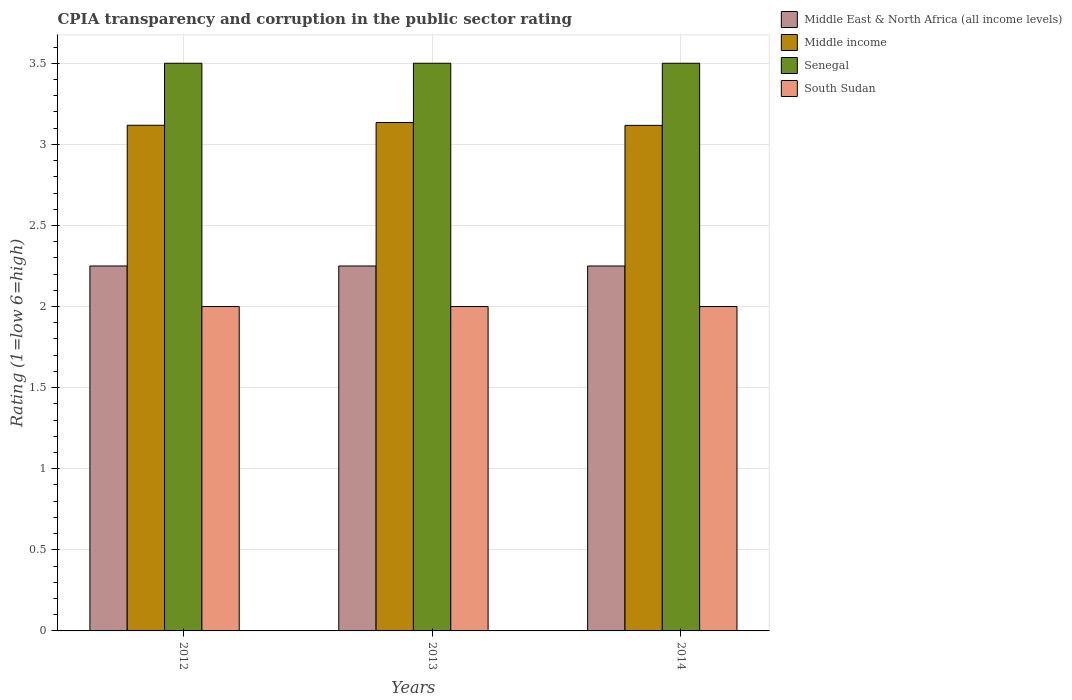How many different coloured bars are there?
Provide a succinct answer. 4. How many bars are there on the 1st tick from the right?
Provide a short and direct response. 4. Across all years, what is the maximum CPIA rating in Middle East & North Africa (all income levels)?
Your response must be concise. 2.25. Across all years, what is the minimum CPIA rating in Senegal?
Provide a succinct answer. 3.5. In which year was the CPIA rating in Middle East & North Africa (all income levels) maximum?
Your answer should be compact. 2012. What is the total CPIA rating in Middle East & North Africa (all income levels) in the graph?
Give a very brief answer. 6.75. What is the difference between the CPIA rating in South Sudan in 2013 and that in 2014?
Your answer should be very brief. 0. What is the difference between the CPIA rating in Middle income in 2014 and the CPIA rating in South Sudan in 2012?
Your answer should be compact. 1.12. In the year 2014, what is the difference between the CPIA rating in Senegal and CPIA rating in Middle income?
Offer a terse response. 0.38. In how many years, is the CPIA rating in Middle income greater than 0.5?
Provide a succinct answer. 3. What is the difference between the highest and the second highest CPIA rating in Senegal?
Keep it short and to the point. 0. What is the difference between the highest and the lowest CPIA rating in Senegal?
Make the answer very short. 0. In how many years, is the CPIA rating in Middle East & North Africa (all income levels) greater than the average CPIA rating in Middle East & North Africa (all income levels) taken over all years?
Your response must be concise. 0. Is the sum of the CPIA rating in Senegal in 2012 and 2014 greater than the maximum CPIA rating in Middle East & North Africa (all income levels) across all years?
Your response must be concise. Yes. Is it the case that in every year, the sum of the CPIA rating in Middle East & North Africa (all income levels) and CPIA rating in Middle income is greater than the sum of CPIA rating in South Sudan and CPIA rating in Senegal?
Your answer should be compact. No. What does the 4th bar from the left in 2013 represents?
Your answer should be very brief. South Sudan. What does the 4th bar from the right in 2012 represents?
Ensure brevity in your answer.  Middle East & North Africa (all income levels). How many bars are there?
Your answer should be very brief. 12. How many years are there in the graph?
Your response must be concise. 3. Are the values on the major ticks of Y-axis written in scientific E-notation?
Make the answer very short. No. What is the title of the graph?
Ensure brevity in your answer.  CPIA transparency and corruption in the public sector rating. What is the label or title of the X-axis?
Provide a short and direct response. Years. What is the Rating (1=low 6=high) in Middle East & North Africa (all income levels) in 2012?
Provide a succinct answer. 2.25. What is the Rating (1=low 6=high) of Middle income in 2012?
Offer a terse response. 3.12. What is the Rating (1=low 6=high) in South Sudan in 2012?
Your response must be concise. 2. What is the Rating (1=low 6=high) of Middle East & North Africa (all income levels) in 2013?
Offer a terse response. 2.25. What is the Rating (1=low 6=high) of Middle income in 2013?
Keep it short and to the point. 3.13. What is the Rating (1=low 6=high) in South Sudan in 2013?
Keep it short and to the point. 2. What is the Rating (1=low 6=high) in Middle East & North Africa (all income levels) in 2014?
Your answer should be very brief. 2.25. What is the Rating (1=low 6=high) in Middle income in 2014?
Ensure brevity in your answer.  3.12. What is the Rating (1=low 6=high) in South Sudan in 2014?
Offer a terse response. 2. Across all years, what is the maximum Rating (1=low 6=high) in Middle East & North Africa (all income levels)?
Make the answer very short. 2.25. Across all years, what is the maximum Rating (1=low 6=high) of Middle income?
Your answer should be very brief. 3.13. Across all years, what is the maximum Rating (1=low 6=high) of Senegal?
Provide a succinct answer. 3.5. Across all years, what is the minimum Rating (1=low 6=high) of Middle East & North Africa (all income levels)?
Give a very brief answer. 2.25. Across all years, what is the minimum Rating (1=low 6=high) of Middle income?
Offer a very short reply. 3.12. Across all years, what is the minimum Rating (1=low 6=high) of South Sudan?
Your answer should be very brief. 2. What is the total Rating (1=low 6=high) of Middle East & North Africa (all income levels) in the graph?
Your answer should be compact. 6.75. What is the total Rating (1=low 6=high) in Middle income in the graph?
Make the answer very short. 9.37. What is the difference between the Rating (1=low 6=high) in Middle income in 2012 and that in 2013?
Provide a succinct answer. -0.02. What is the difference between the Rating (1=low 6=high) in Senegal in 2012 and that in 2013?
Offer a terse response. 0. What is the difference between the Rating (1=low 6=high) of South Sudan in 2012 and that in 2013?
Make the answer very short. 0. What is the difference between the Rating (1=low 6=high) in Middle East & North Africa (all income levels) in 2012 and that in 2014?
Keep it short and to the point. 0. What is the difference between the Rating (1=low 6=high) of Middle income in 2012 and that in 2014?
Offer a very short reply. 0. What is the difference between the Rating (1=low 6=high) in Senegal in 2012 and that in 2014?
Provide a short and direct response. 0. What is the difference between the Rating (1=low 6=high) in South Sudan in 2012 and that in 2014?
Offer a terse response. 0. What is the difference between the Rating (1=low 6=high) of Middle income in 2013 and that in 2014?
Your answer should be very brief. 0.02. What is the difference between the Rating (1=low 6=high) in South Sudan in 2013 and that in 2014?
Give a very brief answer. 0. What is the difference between the Rating (1=low 6=high) of Middle East & North Africa (all income levels) in 2012 and the Rating (1=low 6=high) of Middle income in 2013?
Provide a succinct answer. -0.88. What is the difference between the Rating (1=low 6=high) of Middle East & North Africa (all income levels) in 2012 and the Rating (1=low 6=high) of Senegal in 2013?
Offer a very short reply. -1.25. What is the difference between the Rating (1=low 6=high) of Middle East & North Africa (all income levels) in 2012 and the Rating (1=low 6=high) of South Sudan in 2013?
Provide a short and direct response. 0.25. What is the difference between the Rating (1=low 6=high) of Middle income in 2012 and the Rating (1=low 6=high) of Senegal in 2013?
Provide a succinct answer. -0.38. What is the difference between the Rating (1=low 6=high) in Middle income in 2012 and the Rating (1=low 6=high) in South Sudan in 2013?
Offer a terse response. 1.12. What is the difference between the Rating (1=low 6=high) in Senegal in 2012 and the Rating (1=low 6=high) in South Sudan in 2013?
Keep it short and to the point. 1.5. What is the difference between the Rating (1=low 6=high) of Middle East & North Africa (all income levels) in 2012 and the Rating (1=low 6=high) of Middle income in 2014?
Make the answer very short. -0.87. What is the difference between the Rating (1=low 6=high) in Middle East & North Africa (all income levels) in 2012 and the Rating (1=low 6=high) in Senegal in 2014?
Ensure brevity in your answer.  -1.25. What is the difference between the Rating (1=low 6=high) of Middle income in 2012 and the Rating (1=low 6=high) of Senegal in 2014?
Provide a succinct answer. -0.38. What is the difference between the Rating (1=low 6=high) of Middle income in 2012 and the Rating (1=low 6=high) of South Sudan in 2014?
Provide a succinct answer. 1.12. What is the difference between the Rating (1=low 6=high) in Middle East & North Africa (all income levels) in 2013 and the Rating (1=low 6=high) in Middle income in 2014?
Give a very brief answer. -0.87. What is the difference between the Rating (1=low 6=high) of Middle East & North Africa (all income levels) in 2013 and the Rating (1=low 6=high) of Senegal in 2014?
Your answer should be compact. -1.25. What is the difference between the Rating (1=low 6=high) in Middle income in 2013 and the Rating (1=low 6=high) in Senegal in 2014?
Ensure brevity in your answer.  -0.37. What is the difference between the Rating (1=low 6=high) of Middle income in 2013 and the Rating (1=low 6=high) of South Sudan in 2014?
Your answer should be compact. 1.13. What is the average Rating (1=low 6=high) of Middle East & North Africa (all income levels) per year?
Provide a succinct answer. 2.25. What is the average Rating (1=low 6=high) of Middle income per year?
Offer a terse response. 3.12. What is the average Rating (1=low 6=high) in Senegal per year?
Offer a terse response. 3.5. In the year 2012, what is the difference between the Rating (1=low 6=high) in Middle East & North Africa (all income levels) and Rating (1=low 6=high) in Middle income?
Provide a succinct answer. -0.87. In the year 2012, what is the difference between the Rating (1=low 6=high) in Middle East & North Africa (all income levels) and Rating (1=low 6=high) in Senegal?
Give a very brief answer. -1.25. In the year 2012, what is the difference between the Rating (1=low 6=high) in Middle East & North Africa (all income levels) and Rating (1=low 6=high) in South Sudan?
Your answer should be compact. 0.25. In the year 2012, what is the difference between the Rating (1=low 6=high) in Middle income and Rating (1=low 6=high) in Senegal?
Ensure brevity in your answer.  -0.38. In the year 2012, what is the difference between the Rating (1=low 6=high) of Middle income and Rating (1=low 6=high) of South Sudan?
Provide a short and direct response. 1.12. In the year 2012, what is the difference between the Rating (1=low 6=high) of Senegal and Rating (1=low 6=high) of South Sudan?
Provide a succinct answer. 1.5. In the year 2013, what is the difference between the Rating (1=low 6=high) of Middle East & North Africa (all income levels) and Rating (1=low 6=high) of Middle income?
Your response must be concise. -0.88. In the year 2013, what is the difference between the Rating (1=low 6=high) of Middle East & North Africa (all income levels) and Rating (1=low 6=high) of Senegal?
Your answer should be compact. -1.25. In the year 2013, what is the difference between the Rating (1=low 6=high) of Middle East & North Africa (all income levels) and Rating (1=low 6=high) of South Sudan?
Offer a terse response. 0.25. In the year 2013, what is the difference between the Rating (1=low 6=high) in Middle income and Rating (1=low 6=high) in Senegal?
Make the answer very short. -0.37. In the year 2013, what is the difference between the Rating (1=low 6=high) of Middle income and Rating (1=low 6=high) of South Sudan?
Ensure brevity in your answer.  1.13. In the year 2014, what is the difference between the Rating (1=low 6=high) of Middle East & North Africa (all income levels) and Rating (1=low 6=high) of Middle income?
Ensure brevity in your answer.  -0.87. In the year 2014, what is the difference between the Rating (1=low 6=high) in Middle East & North Africa (all income levels) and Rating (1=low 6=high) in Senegal?
Your answer should be very brief. -1.25. In the year 2014, what is the difference between the Rating (1=low 6=high) of Middle income and Rating (1=low 6=high) of Senegal?
Your answer should be compact. -0.38. In the year 2014, what is the difference between the Rating (1=low 6=high) of Middle income and Rating (1=low 6=high) of South Sudan?
Your answer should be compact. 1.12. In the year 2014, what is the difference between the Rating (1=low 6=high) in Senegal and Rating (1=low 6=high) in South Sudan?
Ensure brevity in your answer.  1.5. What is the ratio of the Rating (1=low 6=high) in Middle income in 2012 to that in 2013?
Make the answer very short. 0.99. What is the ratio of the Rating (1=low 6=high) of Senegal in 2012 to that in 2013?
Offer a terse response. 1. What is the ratio of the Rating (1=low 6=high) in Middle income in 2013 to that in 2014?
Make the answer very short. 1.01. What is the ratio of the Rating (1=low 6=high) in Senegal in 2013 to that in 2014?
Offer a terse response. 1. What is the ratio of the Rating (1=low 6=high) of South Sudan in 2013 to that in 2014?
Your answer should be compact. 1. What is the difference between the highest and the second highest Rating (1=low 6=high) of Middle East & North Africa (all income levels)?
Your answer should be compact. 0. What is the difference between the highest and the second highest Rating (1=low 6=high) in Middle income?
Ensure brevity in your answer.  0.02. What is the difference between the highest and the second highest Rating (1=low 6=high) in Senegal?
Make the answer very short. 0. What is the difference between the highest and the second highest Rating (1=low 6=high) of South Sudan?
Offer a very short reply. 0. What is the difference between the highest and the lowest Rating (1=low 6=high) in Middle income?
Your answer should be very brief. 0.02. What is the difference between the highest and the lowest Rating (1=low 6=high) of Senegal?
Give a very brief answer. 0. What is the difference between the highest and the lowest Rating (1=low 6=high) in South Sudan?
Offer a very short reply. 0. 